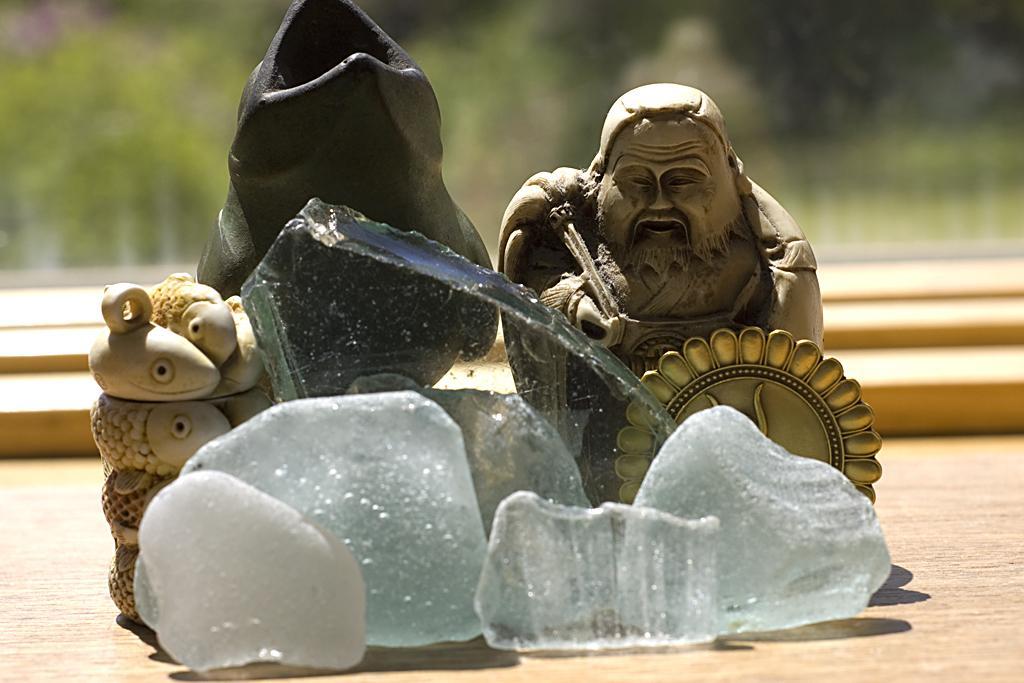How would you summarize this image in a sentence or two? In this image we can see statues. Also there are stones and glass piece. In the background it is blur. 